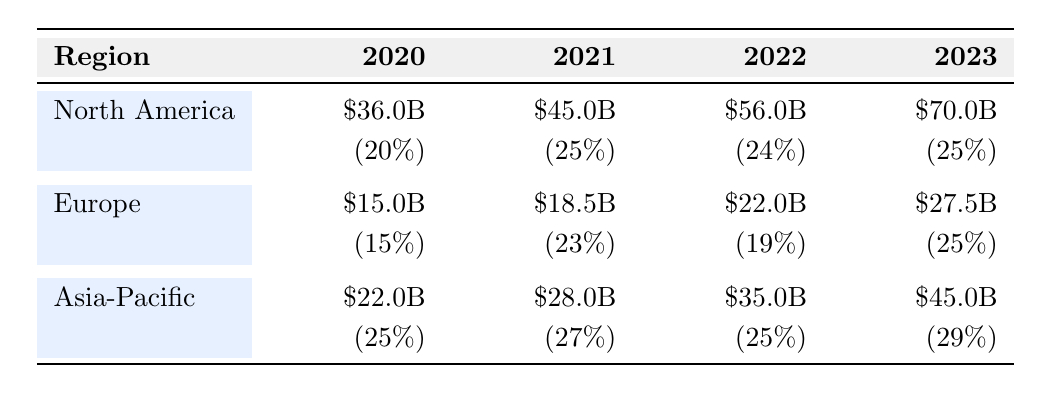What was the total investment in AI technologies in North America from 2020 to 2023? To find the total investment, we need to sum the investments from each year: 36.0 + 45.0 + 56.0 + 70.0 = 207.0 billion USD.
Answer: 207.0 billion USD Which region had the highest investment in 2022? By comparing the investments in 2022, we see North America at 56.0 billion USD, Europe at 22.0 billion USD, and Asia-Pacific at 35.0 billion USD. North America has the highest investment.
Answer: North America What was the percentage growth of AI investment in Europe from 2021 to 2022? The investment in Europe increased from 18.5 billion USD in 2021 to 22.0 billion USD in 2022. The growth rate is calculated using the formula [(22.0 - 18.5) / 18.5] * 100 = 8.11%, which is approximately 19%.
Answer: 19% Is it true that Asia-Pacific had the fastest growth rate in AI investment from 2020 to 2023? By reviewing the growth rates, North America had rates of 20%, 25%, 24%, and 25%; Europe had 15%, 23%, 19%, and 25%; Asia-Pacific had 25%, 27%, 25%, and 29%. The highest growth rate is for Asia-Pacific at 29% in 2023, confirming it is true.
Answer: Yes What is the average investment in AI technologies across all regions for the year 2021? First, we find the investments in 2021: North America (45.0), Europe (18.5), Asia-Pacific (28.0). Summing these gives 45.0 + 18.5 + 28.0 = 91.5 billion USD. Then divide by the number of regions (3): 91.5 / 3 = 30.5 billion USD.
Answer: 30.5 billion USD What is the difference in AI investment between North America and Asia-Pacific in 2023? In 2023, North America invested 70.0 billion USD and Asia-Pacific invested 45.0 billion USD. The difference is 70.0 - 45.0 = 25.0 billion USD.
Answer: 25.0 billion USD Which region saw the smallest investment growth from 2020 to 2023, and what was that growth? The growth in North America was from 36.0 to 70.0 (34.0 billion USD), Europe from 15.0 to 27.5 (12.5 billion USD), and Asia-Pacific from 22.0 to 45.0 (23.0 billion USD). The smallest growth is in Europe.
Answer: Europe, 12.5 billion USD What percentage of the total investment in AI technologies in 2023 does North America represent? In 2023, North America invested 70.0 billion USD, Europe 27.5 billion USD, and Asia-Pacific 45.0 billion USD, totaling 142.5 billion USD. North America's share is (70.0 / 142.5) * 100 = 49.12%, approximately 49%.
Answer: 49% 